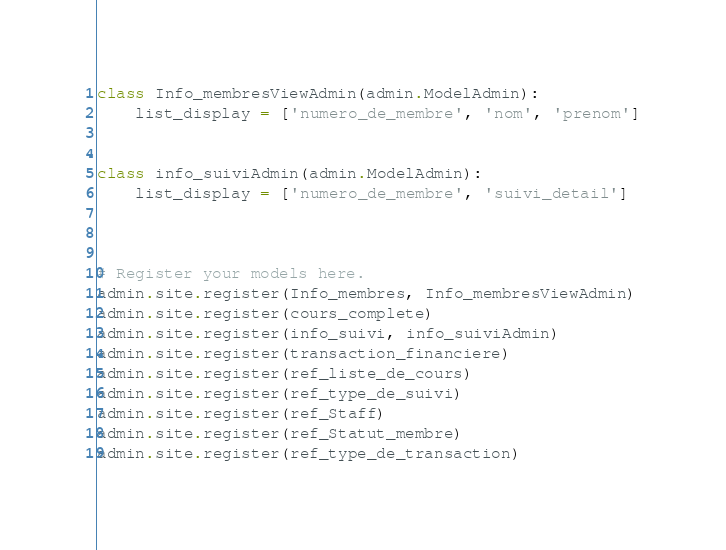<code> <loc_0><loc_0><loc_500><loc_500><_Python_>

class Info_membresViewAdmin(admin.ModelAdmin):
    list_display = ['numero_de_membre', 'nom', 'prenom']


class info_suiviAdmin(admin.ModelAdmin):
    list_display = ['numero_de_membre', 'suivi_detail']



# Register your models here.
admin.site.register(Info_membres, Info_membresViewAdmin)
admin.site.register(cours_complete)
admin.site.register(info_suivi, info_suiviAdmin)
admin.site.register(transaction_financiere)
admin.site.register(ref_liste_de_cours)
admin.site.register(ref_type_de_suivi)
admin.site.register(ref_Staff)
admin.site.register(ref_Statut_membre)
admin.site.register(ref_type_de_transaction)





</code> 